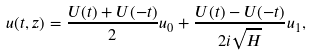<formula> <loc_0><loc_0><loc_500><loc_500>u ( t , z ) = \frac { U ( t ) + U ( - t ) } 2 u _ { 0 } + \frac { U ( t ) - U ( - t ) } { 2 i \sqrt { H } } u _ { 1 } ,</formula> 